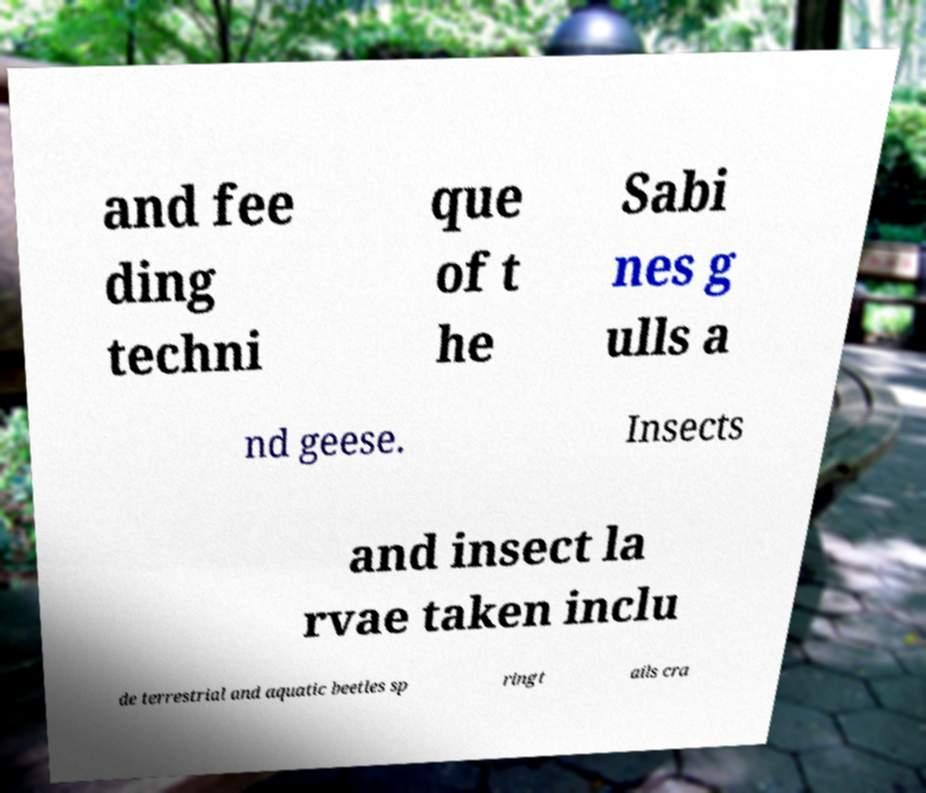I need the written content from this picture converted into text. Can you do that? and fee ding techni que of t he Sabi nes g ulls a nd geese. Insects and insect la rvae taken inclu de terrestrial and aquatic beetles sp ringt ails cra 